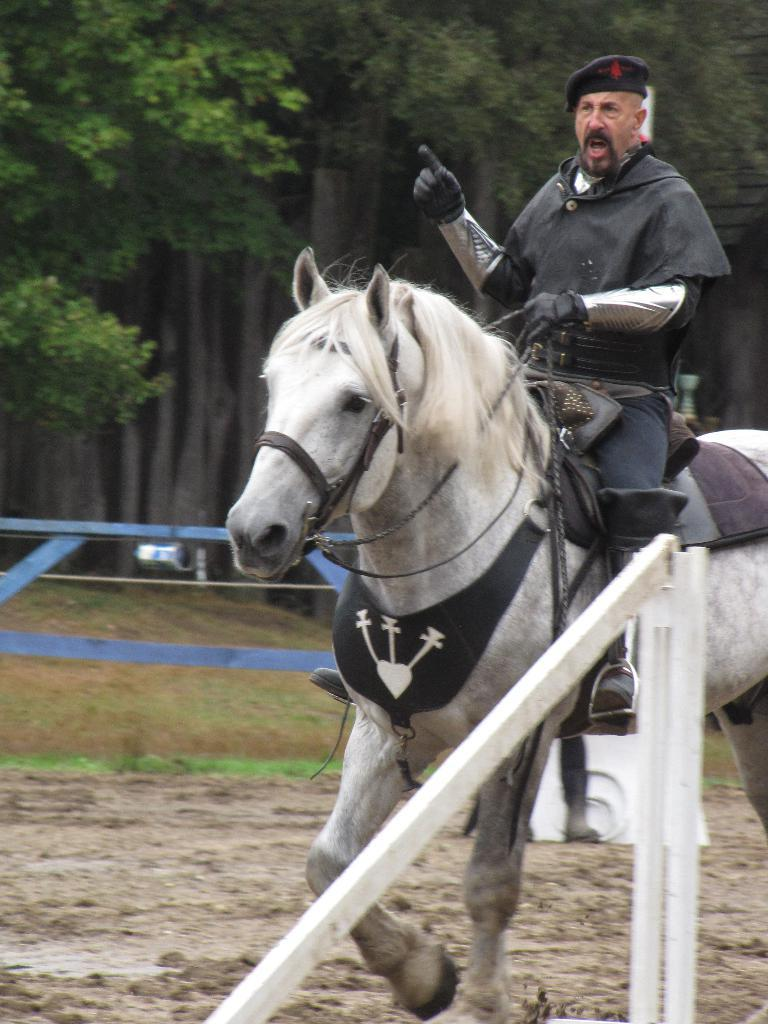Who is present in the image? There is a man in the image. What is the man wearing? The man is wearing a black jacket. What is the man doing in the image? The man is sitting on a horse. What is the horse walking on? The horse is walking on mud. What type of structures can be seen in the image? There are white color wooden stands in the image. What can be seen in the background of the image? There are trees in the background of the image. What type of glue is being used to attach the dolls to the train in the image? There is no train or dolls present in the image; it features a man sitting on a horse with trees in the background. 